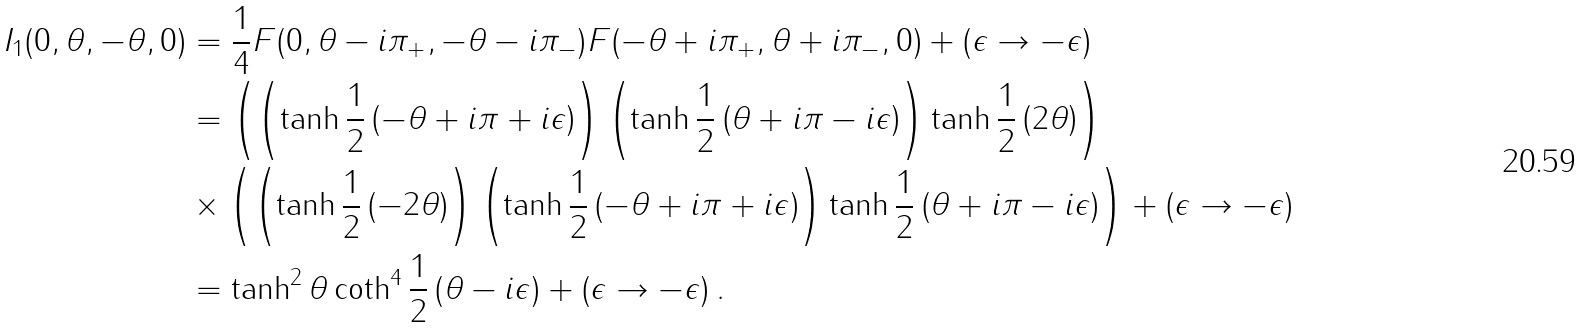<formula> <loc_0><loc_0><loc_500><loc_500>I _ { 1 } ( 0 , \theta , - \theta , 0 ) & = \frac { 1 } { 4 } F ( 0 , \theta - i \pi _ { + } , - \theta - i \pi _ { - } ) F ( - \theta + i \pi _ { + } , \theta + i \pi _ { - } , 0 ) + \left ( \epsilon \rightarrow - \epsilon \right ) \\ & = \left ( \left ( \tanh \frac { 1 } { 2 } \left ( - \theta + i \pi + i \epsilon \right ) \right ) \left ( \tanh \frac { 1 } { 2 } \left ( \theta + i \pi - i \epsilon \right ) \right ) \tanh \frac { 1 } { 2 } \left ( 2 \theta \right ) \right ) \\ & \times \left ( \left ( \tanh \frac { 1 } { 2 } \left ( - 2 \theta \right ) \right ) \left ( \tanh \frac { 1 } { 2 } \left ( - \theta + i \pi + i \epsilon \right ) \right ) \tanh \frac { 1 } { 2 } \left ( \theta + i \pi - i \epsilon \right ) \right ) + \left ( \epsilon \rightarrow - \epsilon \right ) \\ & = \tanh ^ { 2 } \theta \coth ^ { 4 } \frac { 1 } { 2 } \left ( \theta - i \epsilon \right ) + \left ( \epsilon \rightarrow - \epsilon \right ) .</formula> 